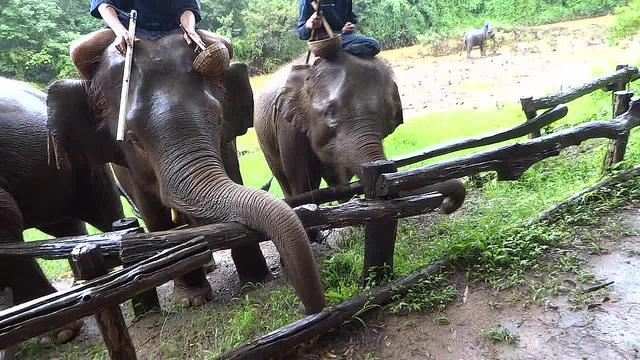What animals are present in the image? Please explain your reasoning. elephant. The trunk is a sure sign that these are elephants. 